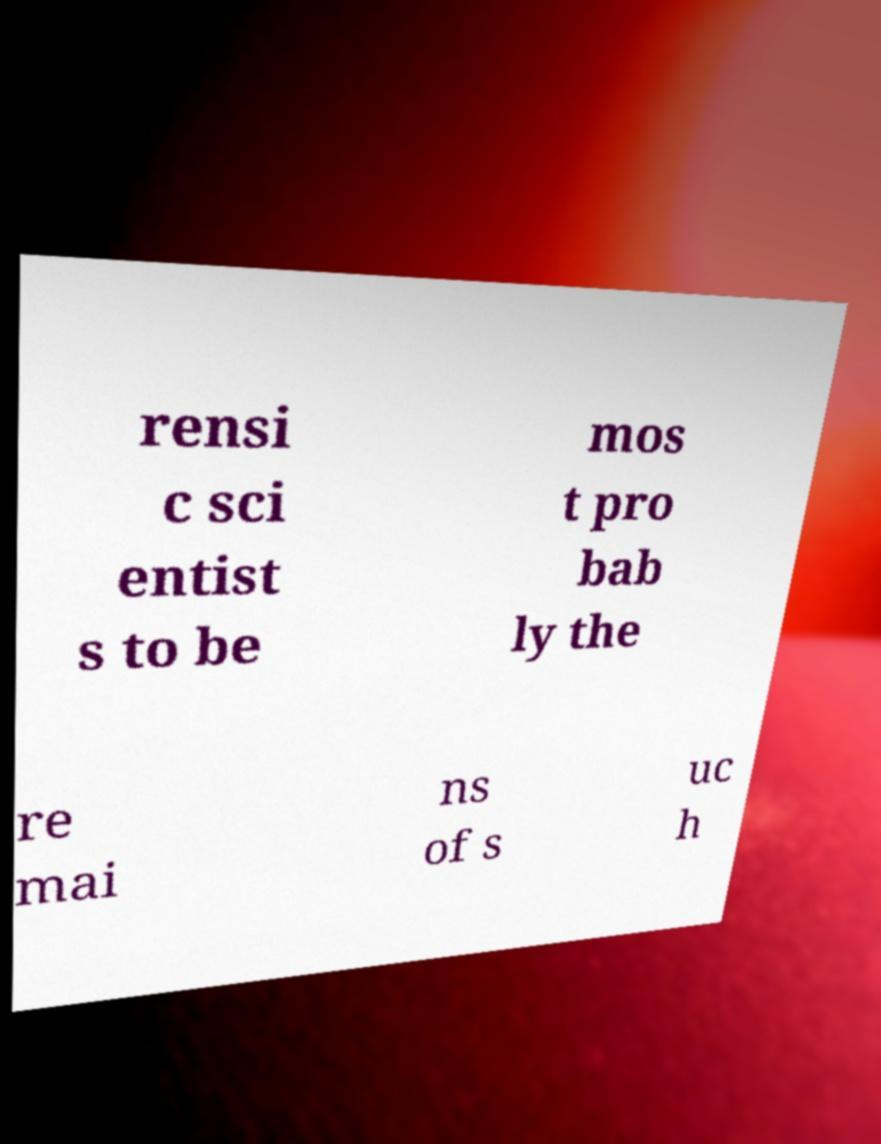Please identify and transcribe the text found in this image. rensi c sci entist s to be mos t pro bab ly the re mai ns of s uc h 